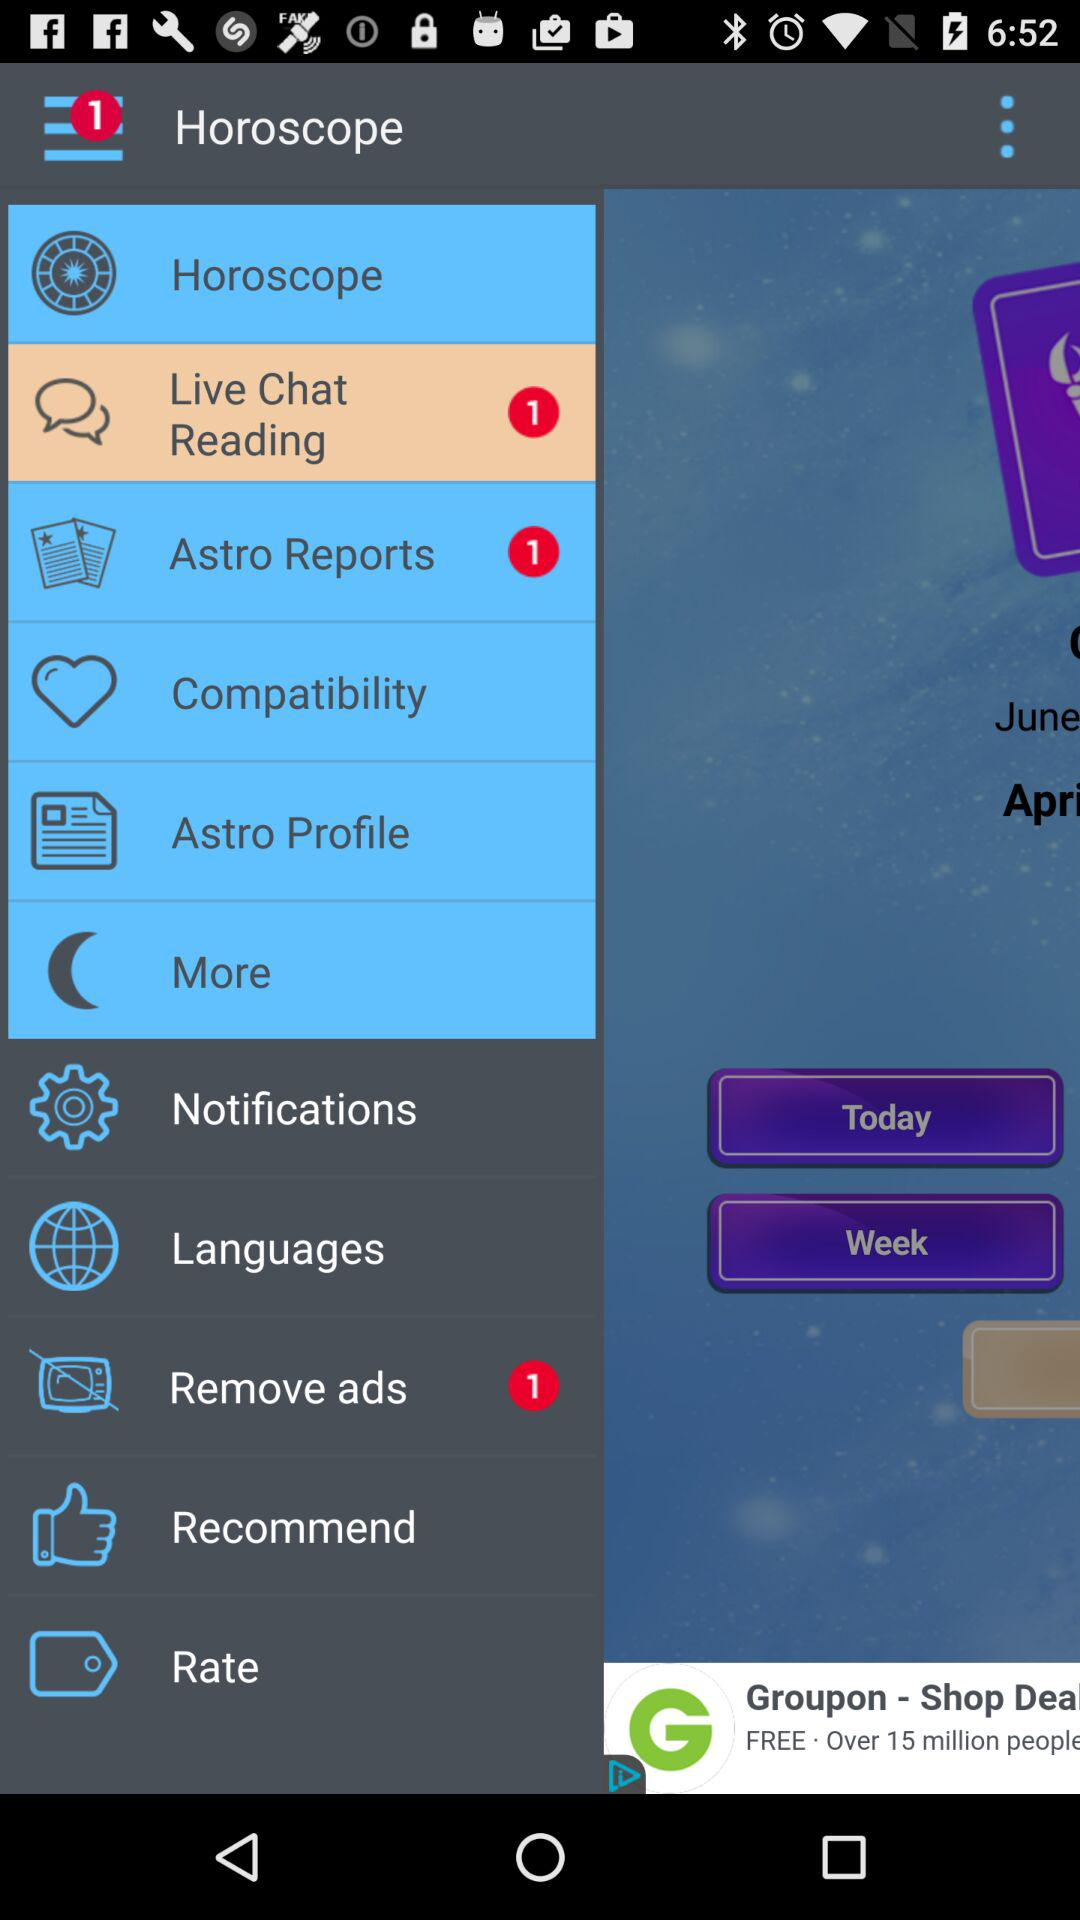How many "Remove ads" notifications are there? There is 1 notification. 